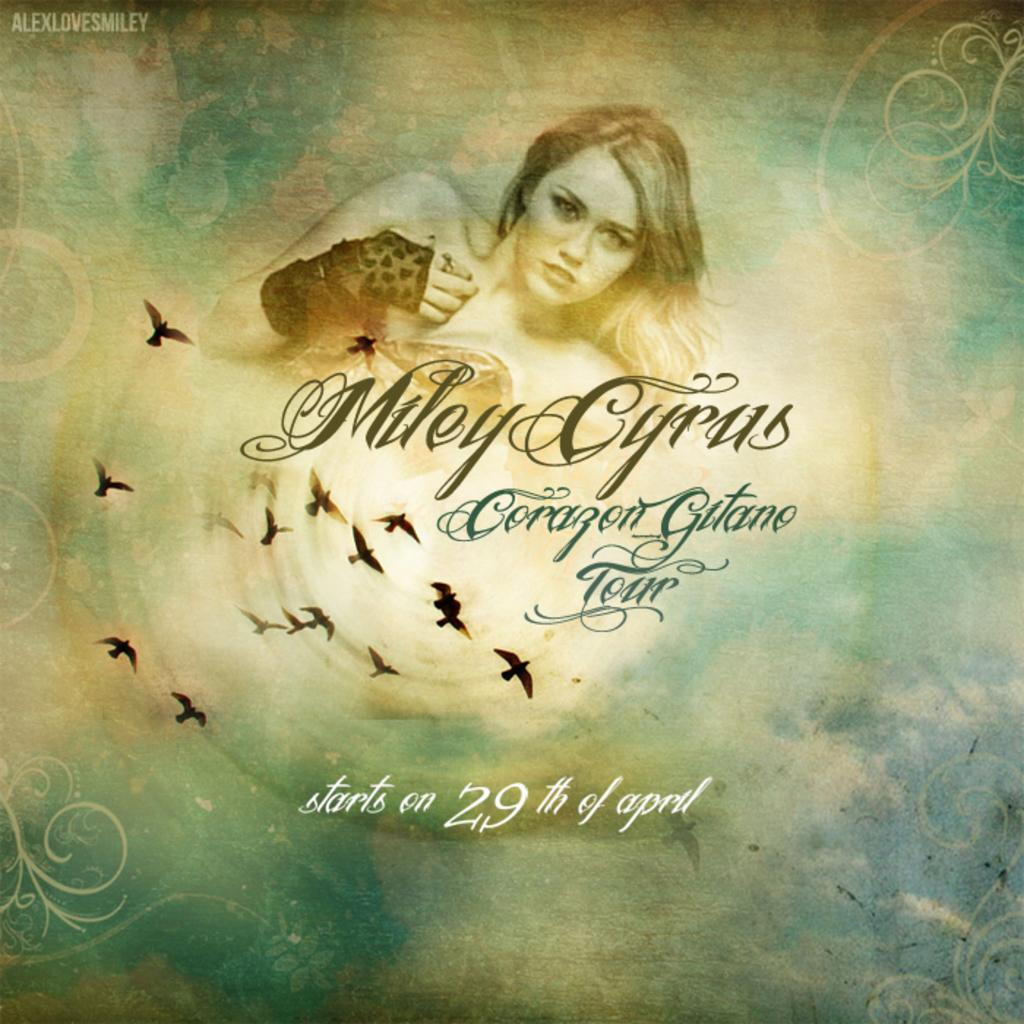<image>
Provide a brief description of the given image. A poster of Miley Cyrus with her name Miley Cyrus below the picture of her.. 